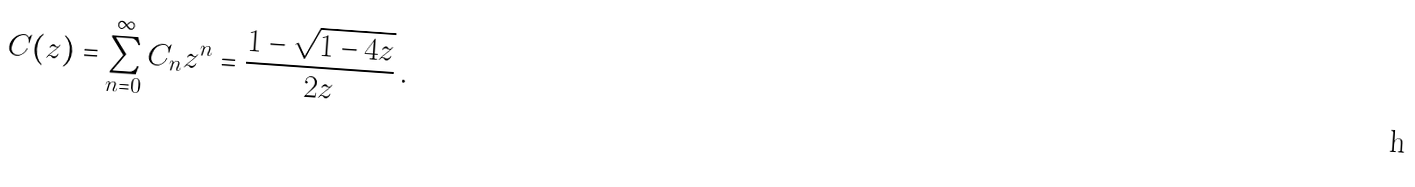<formula> <loc_0><loc_0><loc_500><loc_500>C ( z ) = \sum _ { n = 0 } ^ { \infty } C _ { n } z ^ { n } = \frac { 1 - \sqrt { 1 - 4 z } } { 2 z } \, .</formula> 